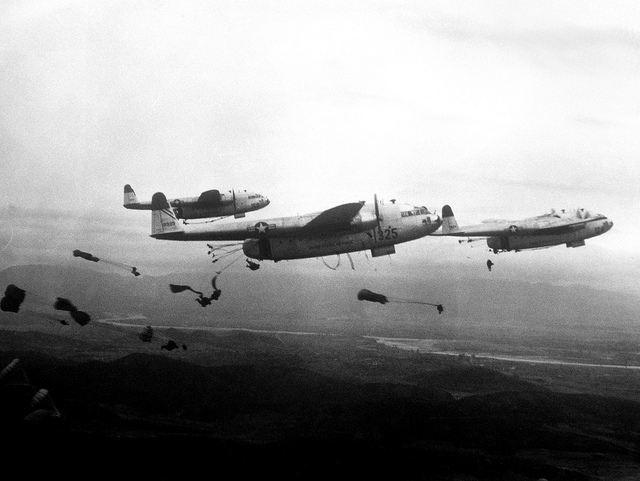Identify the text displayed in this image. 325 